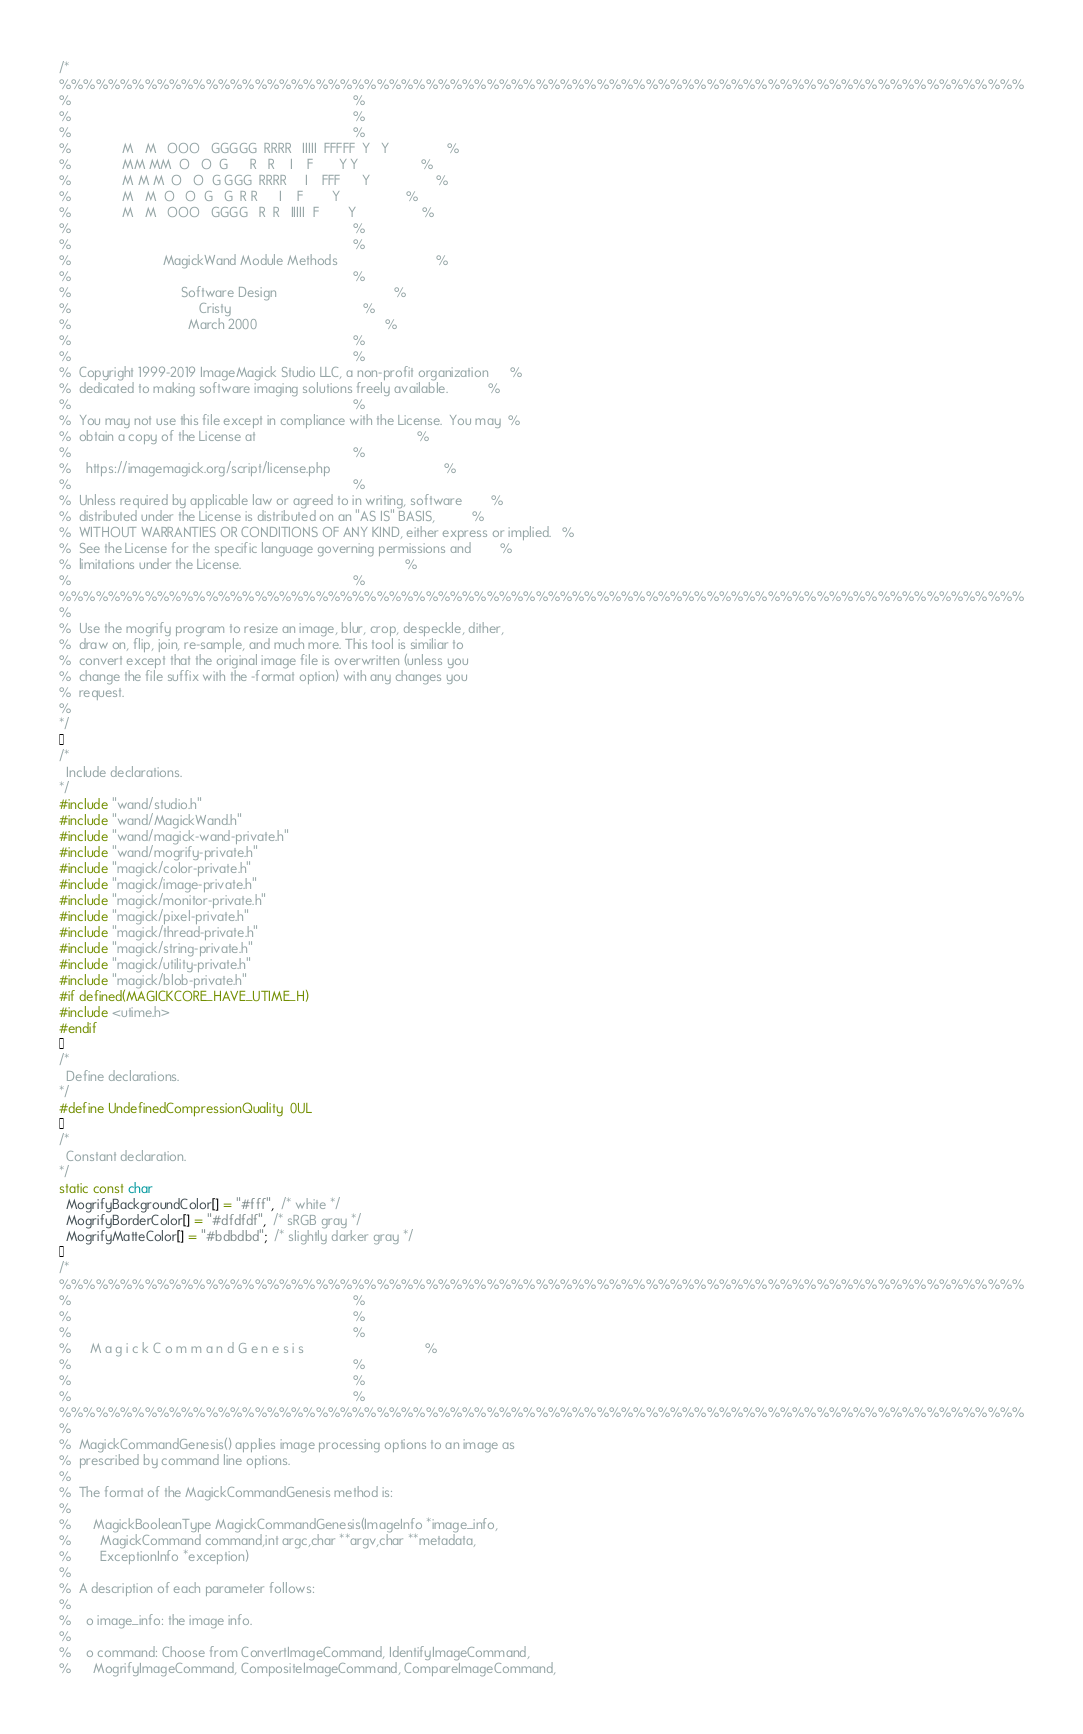Convert code to text. <code><loc_0><loc_0><loc_500><loc_500><_C_>/*
%%%%%%%%%%%%%%%%%%%%%%%%%%%%%%%%%%%%%%%%%%%%%%%%%%%%%%%%%%%%%%%%%%%%%%%%%%%%%%%
%                                                                             %
%                                                                             %
%                                                                             %
%              M   M   OOO   GGGGG  RRRR   IIIII  FFFFF  Y   Y                %
%              MM MM  O   O  G      R   R    I    F       Y Y                 %
%              M M M  O   O  G GGG  RRRR     I    FFF      Y                  %
%              M   M  O   O  G   G  R R      I    F        Y                  %
%              M   M   OOO   GGGG   R  R   IIIII  F        Y                  %
%                                                                             %
%                                                                             %
%                         MagickWand Module Methods                           %
%                                                                             %
%                              Software Design                                %
%                                   Cristy                                    %
%                                March 2000                                   %
%                                                                             %
%                                                                             %
%  Copyright 1999-2019 ImageMagick Studio LLC, a non-profit organization      %
%  dedicated to making software imaging solutions freely available.           %
%                                                                             %
%  You may not use this file except in compliance with the License.  You may  %
%  obtain a copy of the License at                                            %
%                                                                             %
%    https://imagemagick.org/script/license.php                               %
%                                                                             %
%  Unless required by applicable law or agreed to in writing, software        %
%  distributed under the License is distributed on an "AS IS" BASIS,          %
%  WITHOUT WARRANTIES OR CONDITIONS OF ANY KIND, either express or implied.   %
%  See the License for the specific language governing permissions and        %
%  limitations under the License.                                             %
%                                                                             %
%%%%%%%%%%%%%%%%%%%%%%%%%%%%%%%%%%%%%%%%%%%%%%%%%%%%%%%%%%%%%%%%%%%%%%%%%%%%%%%
%
%  Use the mogrify program to resize an image, blur, crop, despeckle, dither,
%  draw on, flip, join, re-sample, and much more. This tool is similiar to
%  convert except that the original image file is overwritten (unless you
%  change the file suffix with the -format option) with any changes you
%  request.
%
*/

/*
  Include declarations.
*/
#include "wand/studio.h"
#include "wand/MagickWand.h"
#include "wand/magick-wand-private.h"
#include "wand/mogrify-private.h"
#include "magick/color-private.h"
#include "magick/image-private.h"
#include "magick/monitor-private.h"
#include "magick/pixel-private.h"
#include "magick/thread-private.h"
#include "magick/string-private.h"
#include "magick/utility-private.h"
#include "magick/blob-private.h"
#if defined(MAGICKCORE_HAVE_UTIME_H)
#include <utime.h>
#endif

/*
  Define declarations.
*/
#define UndefinedCompressionQuality  0UL

/*
  Constant declaration.
*/
static const char
  MogrifyBackgroundColor[] = "#fff",  /* white */
  MogrifyBorderColor[] = "#dfdfdf",  /* sRGB gray */
  MogrifyMatteColor[] = "#bdbdbd";  /* slightly darker gray */

/*
%%%%%%%%%%%%%%%%%%%%%%%%%%%%%%%%%%%%%%%%%%%%%%%%%%%%%%%%%%%%%%%%%%%%%%%%%%%%%%%
%                                                                             %
%                                                                             %
%                                                                             %
%     M a g i c k C o m m a n d G e n e s i s                                 %
%                                                                             %
%                                                                             %
%                                                                             %
%%%%%%%%%%%%%%%%%%%%%%%%%%%%%%%%%%%%%%%%%%%%%%%%%%%%%%%%%%%%%%%%%%%%%%%%%%%%%%%
%
%  MagickCommandGenesis() applies image processing options to an image as
%  prescribed by command line options.
%
%  The format of the MagickCommandGenesis method is:
%
%      MagickBooleanType MagickCommandGenesis(ImageInfo *image_info,
%        MagickCommand command,int argc,char **argv,char **metadata,
%        ExceptionInfo *exception)
%
%  A description of each parameter follows:
%
%    o image_info: the image info.
%
%    o command: Choose from ConvertImageCommand, IdentifyImageCommand,
%      MogrifyImageCommand, CompositeImageCommand, CompareImageCommand,</code> 